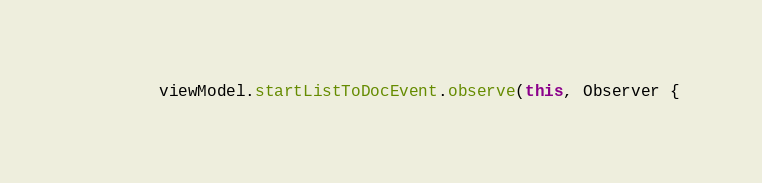Convert code to text. <code><loc_0><loc_0><loc_500><loc_500><_Kotlin_>        viewModel.startListToDocEvent.observe(this, Observer {</code> 